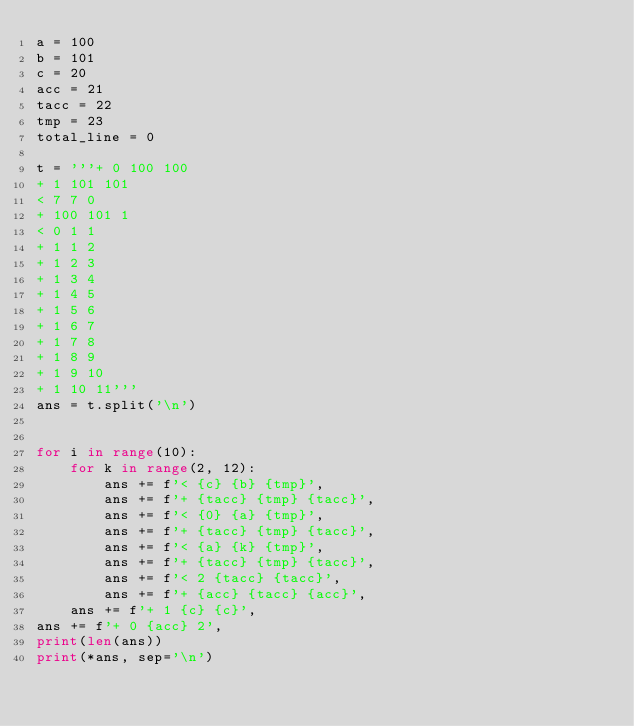Convert code to text. <code><loc_0><loc_0><loc_500><loc_500><_Python_>a = 100
b = 101
c = 20
acc = 21
tacc = 22
tmp = 23
total_line = 0

t = '''+ 0 100 100
+ 1 101 101
< 7 7 0
+ 100 101 1
< 0 1 1
+ 1 1 2
+ 1 2 3
+ 1 3 4
+ 1 4 5
+ 1 5 6
+ 1 6 7
+ 1 7 8
+ 1 8 9
+ 1 9 10
+ 1 10 11'''
ans = t.split('\n')


for i in range(10):
    for k in range(2, 12):
        ans += f'< {c} {b} {tmp}',
        ans += f'+ {tacc} {tmp} {tacc}',
        ans += f'< {0} {a} {tmp}',
        ans += f'+ {tacc} {tmp} {tacc}',
        ans += f'< {a} {k} {tmp}',
        ans += f'+ {tacc} {tmp} {tacc}',
        ans += f'< 2 {tacc} {tacc}',
        ans += f'+ {acc} {tacc} {acc}',
    ans += f'+ 1 {c} {c}',
ans += f'+ 0 {acc} 2',
print(len(ans))
print(*ans, sep='\n')
</code> 